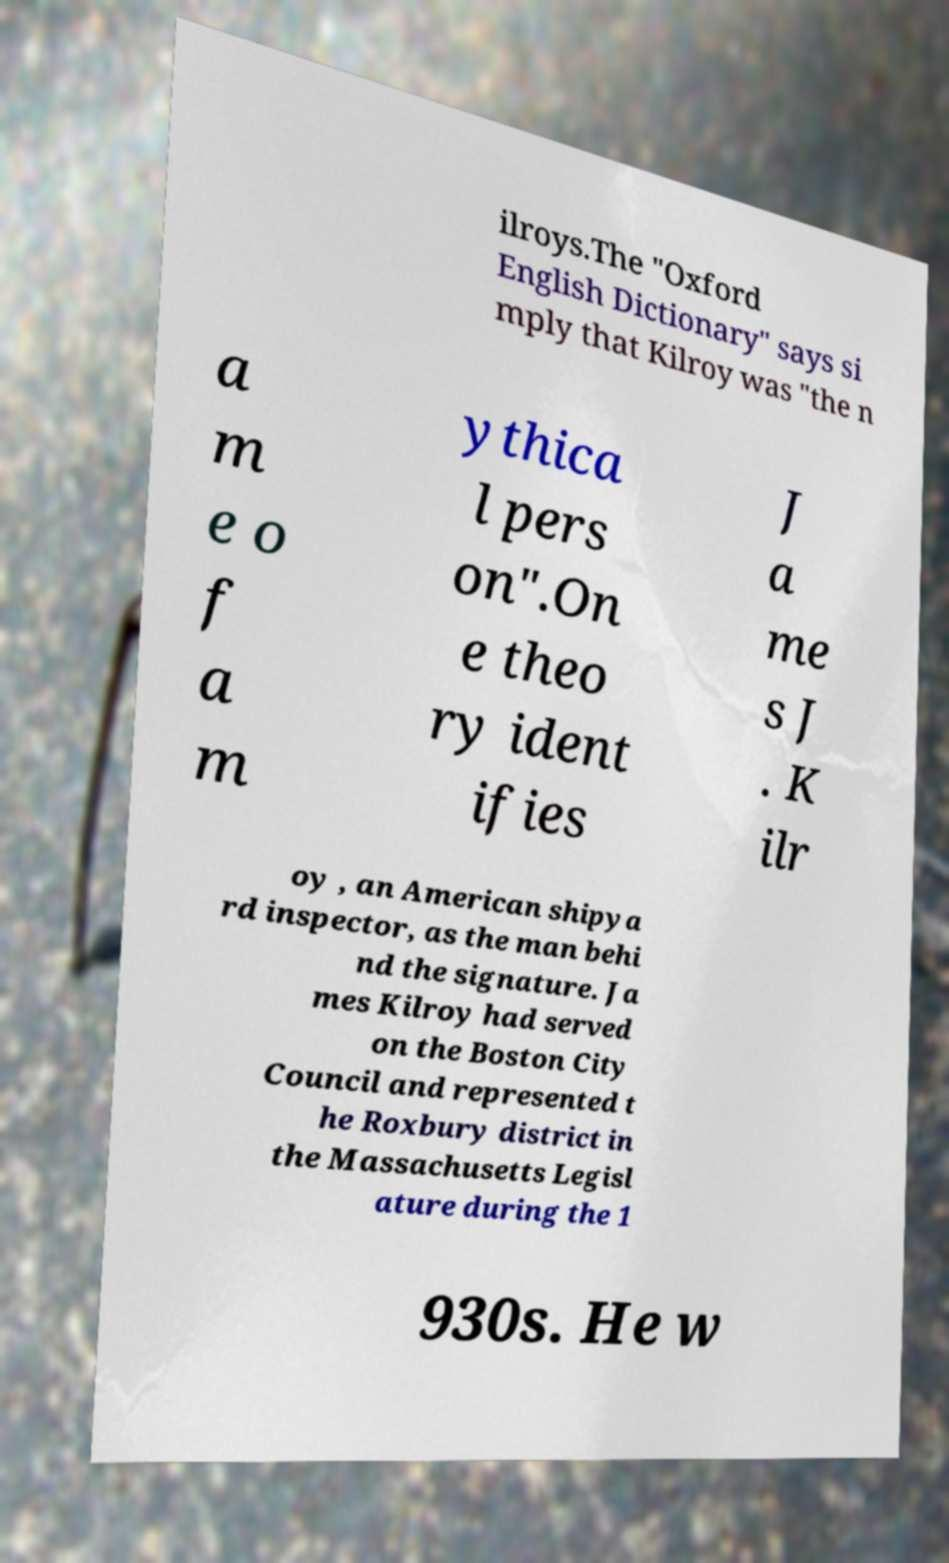Please identify and transcribe the text found in this image. ilroys.The "Oxford English Dictionary" says si mply that Kilroy was "the n a m e o f a m ythica l pers on".On e theo ry ident ifies J a me s J . K ilr oy , an American shipya rd inspector, as the man behi nd the signature. Ja mes Kilroy had served on the Boston City Council and represented t he Roxbury district in the Massachusetts Legisl ature during the 1 930s. He w 